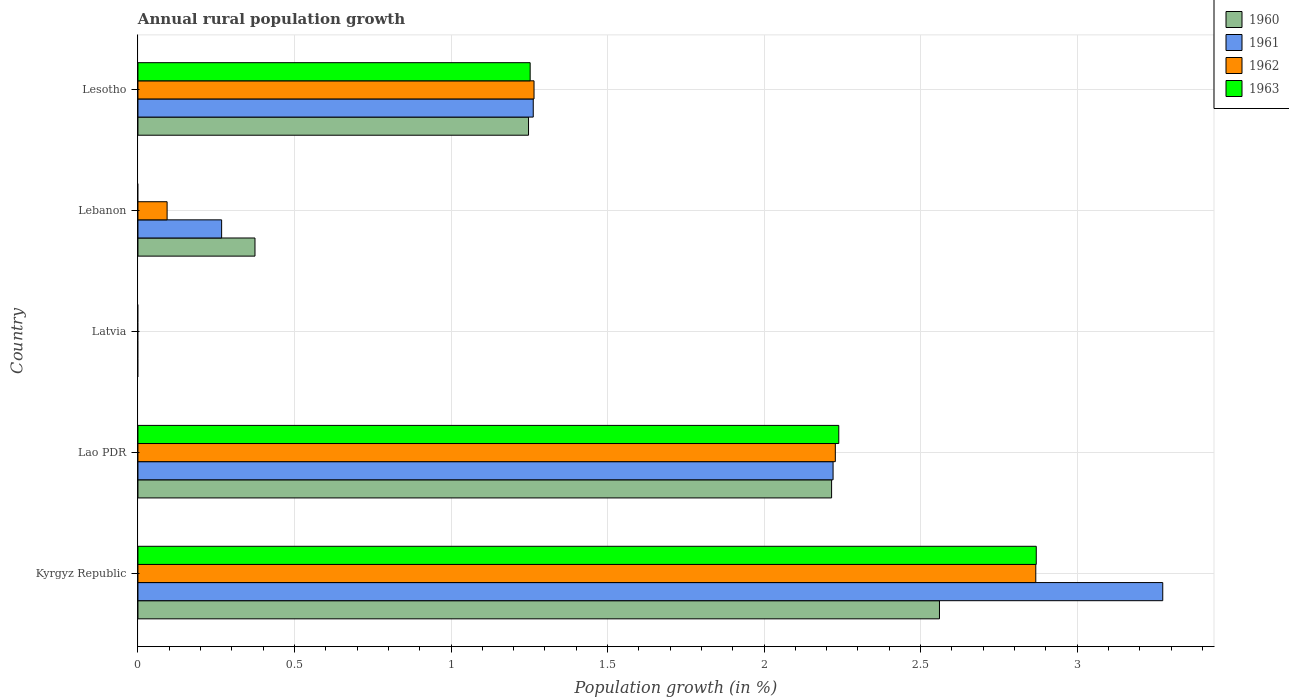Are the number of bars per tick equal to the number of legend labels?
Keep it short and to the point. No. Are the number of bars on each tick of the Y-axis equal?
Offer a very short reply. No. How many bars are there on the 5th tick from the top?
Offer a very short reply. 4. What is the label of the 1st group of bars from the top?
Keep it short and to the point. Lesotho. In how many cases, is the number of bars for a given country not equal to the number of legend labels?
Keep it short and to the point. 2. What is the percentage of rural population growth in 1960 in Lebanon?
Provide a short and direct response. 0.37. Across all countries, what is the maximum percentage of rural population growth in 1962?
Provide a succinct answer. 2.87. Across all countries, what is the minimum percentage of rural population growth in 1960?
Your answer should be compact. 0. In which country was the percentage of rural population growth in 1962 maximum?
Your answer should be compact. Kyrgyz Republic. What is the total percentage of rural population growth in 1961 in the graph?
Make the answer very short. 7.02. What is the difference between the percentage of rural population growth in 1960 in Kyrgyz Republic and that in Lebanon?
Your answer should be very brief. 2.19. What is the difference between the percentage of rural population growth in 1963 in Kyrgyz Republic and the percentage of rural population growth in 1960 in Lesotho?
Ensure brevity in your answer.  1.62. What is the average percentage of rural population growth in 1962 per country?
Ensure brevity in your answer.  1.29. What is the difference between the percentage of rural population growth in 1960 and percentage of rural population growth in 1963 in Lao PDR?
Your answer should be compact. -0.02. What is the ratio of the percentage of rural population growth in 1962 in Lao PDR to that in Lesotho?
Your response must be concise. 1.76. What is the difference between the highest and the second highest percentage of rural population growth in 1962?
Provide a short and direct response. 0.64. What is the difference between the highest and the lowest percentage of rural population growth in 1963?
Provide a succinct answer. 2.87. How many bars are there?
Offer a very short reply. 15. What is the difference between two consecutive major ticks on the X-axis?
Make the answer very short. 0.5. Does the graph contain any zero values?
Your response must be concise. Yes. How many legend labels are there?
Your answer should be very brief. 4. How are the legend labels stacked?
Make the answer very short. Vertical. What is the title of the graph?
Provide a short and direct response. Annual rural population growth. What is the label or title of the X-axis?
Offer a terse response. Population growth (in %). What is the label or title of the Y-axis?
Keep it short and to the point. Country. What is the Population growth (in %) in 1960 in Kyrgyz Republic?
Provide a short and direct response. 2.56. What is the Population growth (in %) in 1961 in Kyrgyz Republic?
Keep it short and to the point. 3.27. What is the Population growth (in %) in 1962 in Kyrgyz Republic?
Your response must be concise. 2.87. What is the Population growth (in %) of 1963 in Kyrgyz Republic?
Ensure brevity in your answer.  2.87. What is the Population growth (in %) of 1960 in Lao PDR?
Offer a very short reply. 2.22. What is the Population growth (in %) in 1961 in Lao PDR?
Your answer should be compact. 2.22. What is the Population growth (in %) of 1962 in Lao PDR?
Offer a very short reply. 2.23. What is the Population growth (in %) of 1963 in Lao PDR?
Your response must be concise. 2.24. What is the Population growth (in %) in 1961 in Latvia?
Provide a succinct answer. 0. What is the Population growth (in %) of 1962 in Latvia?
Your response must be concise. 0. What is the Population growth (in %) of 1963 in Latvia?
Offer a terse response. 0. What is the Population growth (in %) in 1960 in Lebanon?
Give a very brief answer. 0.37. What is the Population growth (in %) of 1961 in Lebanon?
Offer a terse response. 0.27. What is the Population growth (in %) in 1962 in Lebanon?
Keep it short and to the point. 0.09. What is the Population growth (in %) of 1963 in Lebanon?
Keep it short and to the point. 0. What is the Population growth (in %) in 1960 in Lesotho?
Ensure brevity in your answer.  1.25. What is the Population growth (in %) in 1961 in Lesotho?
Offer a very short reply. 1.26. What is the Population growth (in %) of 1962 in Lesotho?
Offer a terse response. 1.27. What is the Population growth (in %) in 1963 in Lesotho?
Ensure brevity in your answer.  1.25. Across all countries, what is the maximum Population growth (in %) of 1960?
Provide a short and direct response. 2.56. Across all countries, what is the maximum Population growth (in %) of 1961?
Offer a terse response. 3.27. Across all countries, what is the maximum Population growth (in %) of 1962?
Provide a short and direct response. 2.87. Across all countries, what is the maximum Population growth (in %) in 1963?
Provide a short and direct response. 2.87. Across all countries, what is the minimum Population growth (in %) in 1962?
Offer a terse response. 0. Across all countries, what is the minimum Population growth (in %) in 1963?
Give a very brief answer. 0. What is the total Population growth (in %) in 1960 in the graph?
Offer a terse response. 6.4. What is the total Population growth (in %) of 1961 in the graph?
Offer a very short reply. 7.02. What is the total Population growth (in %) in 1962 in the graph?
Give a very brief answer. 6.45. What is the total Population growth (in %) of 1963 in the graph?
Ensure brevity in your answer.  6.36. What is the difference between the Population growth (in %) of 1960 in Kyrgyz Republic and that in Lao PDR?
Your answer should be very brief. 0.34. What is the difference between the Population growth (in %) in 1961 in Kyrgyz Republic and that in Lao PDR?
Your response must be concise. 1.05. What is the difference between the Population growth (in %) of 1962 in Kyrgyz Republic and that in Lao PDR?
Keep it short and to the point. 0.64. What is the difference between the Population growth (in %) in 1963 in Kyrgyz Republic and that in Lao PDR?
Your response must be concise. 0.63. What is the difference between the Population growth (in %) in 1960 in Kyrgyz Republic and that in Lebanon?
Offer a terse response. 2.19. What is the difference between the Population growth (in %) in 1961 in Kyrgyz Republic and that in Lebanon?
Your answer should be very brief. 3.01. What is the difference between the Population growth (in %) in 1962 in Kyrgyz Republic and that in Lebanon?
Offer a very short reply. 2.77. What is the difference between the Population growth (in %) in 1960 in Kyrgyz Republic and that in Lesotho?
Give a very brief answer. 1.31. What is the difference between the Population growth (in %) in 1961 in Kyrgyz Republic and that in Lesotho?
Your answer should be very brief. 2.01. What is the difference between the Population growth (in %) in 1962 in Kyrgyz Republic and that in Lesotho?
Make the answer very short. 1.6. What is the difference between the Population growth (in %) in 1963 in Kyrgyz Republic and that in Lesotho?
Your answer should be compact. 1.62. What is the difference between the Population growth (in %) of 1960 in Lao PDR and that in Lebanon?
Ensure brevity in your answer.  1.84. What is the difference between the Population growth (in %) in 1961 in Lao PDR and that in Lebanon?
Your answer should be compact. 1.95. What is the difference between the Population growth (in %) in 1962 in Lao PDR and that in Lebanon?
Your answer should be compact. 2.13. What is the difference between the Population growth (in %) in 1960 in Lao PDR and that in Lesotho?
Your response must be concise. 0.97. What is the difference between the Population growth (in %) in 1961 in Lao PDR and that in Lesotho?
Make the answer very short. 0.96. What is the difference between the Population growth (in %) of 1962 in Lao PDR and that in Lesotho?
Keep it short and to the point. 0.96. What is the difference between the Population growth (in %) in 1963 in Lao PDR and that in Lesotho?
Your answer should be very brief. 0.99. What is the difference between the Population growth (in %) in 1960 in Lebanon and that in Lesotho?
Your answer should be very brief. -0.87. What is the difference between the Population growth (in %) of 1961 in Lebanon and that in Lesotho?
Give a very brief answer. -1. What is the difference between the Population growth (in %) in 1962 in Lebanon and that in Lesotho?
Offer a terse response. -1.17. What is the difference between the Population growth (in %) of 1960 in Kyrgyz Republic and the Population growth (in %) of 1961 in Lao PDR?
Keep it short and to the point. 0.34. What is the difference between the Population growth (in %) of 1960 in Kyrgyz Republic and the Population growth (in %) of 1962 in Lao PDR?
Ensure brevity in your answer.  0.33. What is the difference between the Population growth (in %) in 1960 in Kyrgyz Republic and the Population growth (in %) in 1963 in Lao PDR?
Your answer should be compact. 0.32. What is the difference between the Population growth (in %) of 1961 in Kyrgyz Republic and the Population growth (in %) of 1962 in Lao PDR?
Provide a short and direct response. 1.05. What is the difference between the Population growth (in %) in 1961 in Kyrgyz Republic and the Population growth (in %) in 1963 in Lao PDR?
Keep it short and to the point. 1.03. What is the difference between the Population growth (in %) in 1962 in Kyrgyz Republic and the Population growth (in %) in 1963 in Lao PDR?
Offer a terse response. 0.63. What is the difference between the Population growth (in %) in 1960 in Kyrgyz Republic and the Population growth (in %) in 1961 in Lebanon?
Your response must be concise. 2.29. What is the difference between the Population growth (in %) of 1960 in Kyrgyz Republic and the Population growth (in %) of 1962 in Lebanon?
Your answer should be very brief. 2.47. What is the difference between the Population growth (in %) of 1961 in Kyrgyz Republic and the Population growth (in %) of 1962 in Lebanon?
Your response must be concise. 3.18. What is the difference between the Population growth (in %) in 1960 in Kyrgyz Republic and the Population growth (in %) in 1961 in Lesotho?
Make the answer very short. 1.3. What is the difference between the Population growth (in %) of 1960 in Kyrgyz Republic and the Population growth (in %) of 1962 in Lesotho?
Your answer should be compact. 1.3. What is the difference between the Population growth (in %) of 1960 in Kyrgyz Republic and the Population growth (in %) of 1963 in Lesotho?
Your response must be concise. 1.31. What is the difference between the Population growth (in %) of 1961 in Kyrgyz Republic and the Population growth (in %) of 1962 in Lesotho?
Your answer should be compact. 2.01. What is the difference between the Population growth (in %) of 1961 in Kyrgyz Republic and the Population growth (in %) of 1963 in Lesotho?
Provide a short and direct response. 2.02. What is the difference between the Population growth (in %) of 1962 in Kyrgyz Republic and the Population growth (in %) of 1963 in Lesotho?
Your response must be concise. 1.62. What is the difference between the Population growth (in %) of 1960 in Lao PDR and the Population growth (in %) of 1961 in Lebanon?
Keep it short and to the point. 1.95. What is the difference between the Population growth (in %) in 1960 in Lao PDR and the Population growth (in %) in 1962 in Lebanon?
Provide a succinct answer. 2.12. What is the difference between the Population growth (in %) of 1961 in Lao PDR and the Population growth (in %) of 1962 in Lebanon?
Keep it short and to the point. 2.13. What is the difference between the Population growth (in %) in 1960 in Lao PDR and the Population growth (in %) in 1961 in Lesotho?
Provide a succinct answer. 0.95. What is the difference between the Population growth (in %) of 1960 in Lao PDR and the Population growth (in %) of 1962 in Lesotho?
Give a very brief answer. 0.95. What is the difference between the Population growth (in %) in 1960 in Lao PDR and the Population growth (in %) in 1963 in Lesotho?
Keep it short and to the point. 0.96. What is the difference between the Population growth (in %) in 1961 in Lao PDR and the Population growth (in %) in 1962 in Lesotho?
Your response must be concise. 0.96. What is the difference between the Population growth (in %) in 1961 in Lao PDR and the Population growth (in %) in 1963 in Lesotho?
Offer a very short reply. 0.97. What is the difference between the Population growth (in %) in 1962 in Lao PDR and the Population growth (in %) in 1963 in Lesotho?
Offer a very short reply. 0.97. What is the difference between the Population growth (in %) in 1960 in Lebanon and the Population growth (in %) in 1961 in Lesotho?
Give a very brief answer. -0.89. What is the difference between the Population growth (in %) in 1960 in Lebanon and the Population growth (in %) in 1962 in Lesotho?
Your answer should be very brief. -0.89. What is the difference between the Population growth (in %) in 1960 in Lebanon and the Population growth (in %) in 1963 in Lesotho?
Offer a very short reply. -0.88. What is the difference between the Population growth (in %) in 1961 in Lebanon and the Population growth (in %) in 1962 in Lesotho?
Your answer should be very brief. -1. What is the difference between the Population growth (in %) of 1961 in Lebanon and the Population growth (in %) of 1963 in Lesotho?
Provide a succinct answer. -0.99. What is the difference between the Population growth (in %) of 1962 in Lebanon and the Population growth (in %) of 1963 in Lesotho?
Make the answer very short. -1.16. What is the average Population growth (in %) of 1960 per country?
Provide a succinct answer. 1.28. What is the average Population growth (in %) in 1961 per country?
Offer a very short reply. 1.4. What is the average Population growth (in %) of 1962 per country?
Give a very brief answer. 1.29. What is the average Population growth (in %) in 1963 per country?
Give a very brief answer. 1.27. What is the difference between the Population growth (in %) in 1960 and Population growth (in %) in 1961 in Kyrgyz Republic?
Your answer should be very brief. -0.71. What is the difference between the Population growth (in %) in 1960 and Population growth (in %) in 1962 in Kyrgyz Republic?
Provide a short and direct response. -0.31. What is the difference between the Population growth (in %) of 1960 and Population growth (in %) of 1963 in Kyrgyz Republic?
Provide a short and direct response. -0.31. What is the difference between the Population growth (in %) in 1961 and Population growth (in %) in 1962 in Kyrgyz Republic?
Provide a short and direct response. 0.41. What is the difference between the Population growth (in %) in 1961 and Population growth (in %) in 1963 in Kyrgyz Republic?
Your answer should be very brief. 0.4. What is the difference between the Population growth (in %) in 1962 and Population growth (in %) in 1963 in Kyrgyz Republic?
Offer a very short reply. -0. What is the difference between the Population growth (in %) in 1960 and Population growth (in %) in 1961 in Lao PDR?
Your response must be concise. -0. What is the difference between the Population growth (in %) of 1960 and Population growth (in %) of 1962 in Lao PDR?
Make the answer very short. -0.01. What is the difference between the Population growth (in %) in 1960 and Population growth (in %) in 1963 in Lao PDR?
Provide a succinct answer. -0.02. What is the difference between the Population growth (in %) of 1961 and Population growth (in %) of 1962 in Lao PDR?
Make the answer very short. -0.01. What is the difference between the Population growth (in %) of 1961 and Population growth (in %) of 1963 in Lao PDR?
Provide a succinct answer. -0.02. What is the difference between the Population growth (in %) of 1962 and Population growth (in %) of 1963 in Lao PDR?
Offer a terse response. -0.01. What is the difference between the Population growth (in %) of 1960 and Population growth (in %) of 1961 in Lebanon?
Your response must be concise. 0.11. What is the difference between the Population growth (in %) in 1960 and Population growth (in %) in 1962 in Lebanon?
Offer a terse response. 0.28. What is the difference between the Population growth (in %) in 1961 and Population growth (in %) in 1962 in Lebanon?
Offer a very short reply. 0.17. What is the difference between the Population growth (in %) in 1960 and Population growth (in %) in 1961 in Lesotho?
Your response must be concise. -0.01. What is the difference between the Population growth (in %) of 1960 and Population growth (in %) of 1962 in Lesotho?
Offer a very short reply. -0.02. What is the difference between the Population growth (in %) in 1960 and Population growth (in %) in 1963 in Lesotho?
Your answer should be very brief. -0.01. What is the difference between the Population growth (in %) in 1961 and Population growth (in %) in 1962 in Lesotho?
Your response must be concise. -0. What is the difference between the Population growth (in %) in 1961 and Population growth (in %) in 1963 in Lesotho?
Offer a terse response. 0.01. What is the difference between the Population growth (in %) in 1962 and Population growth (in %) in 1963 in Lesotho?
Offer a very short reply. 0.01. What is the ratio of the Population growth (in %) of 1960 in Kyrgyz Republic to that in Lao PDR?
Your response must be concise. 1.16. What is the ratio of the Population growth (in %) in 1961 in Kyrgyz Republic to that in Lao PDR?
Ensure brevity in your answer.  1.47. What is the ratio of the Population growth (in %) of 1962 in Kyrgyz Republic to that in Lao PDR?
Make the answer very short. 1.29. What is the ratio of the Population growth (in %) in 1963 in Kyrgyz Republic to that in Lao PDR?
Make the answer very short. 1.28. What is the ratio of the Population growth (in %) in 1960 in Kyrgyz Republic to that in Lebanon?
Your answer should be compact. 6.85. What is the ratio of the Population growth (in %) in 1961 in Kyrgyz Republic to that in Lebanon?
Make the answer very short. 12.25. What is the ratio of the Population growth (in %) of 1962 in Kyrgyz Republic to that in Lebanon?
Offer a terse response. 30.8. What is the ratio of the Population growth (in %) of 1960 in Kyrgyz Republic to that in Lesotho?
Your answer should be compact. 2.05. What is the ratio of the Population growth (in %) of 1961 in Kyrgyz Republic to that in Lesotho?
Provide a short and direct response. 2.59. What is the ratio of the Population growth (in %) in 1962 in Kyrgyz Republic to that in Lesotho?
Your response must be concise. 2.27. What is the ratio of the Population growth (in %) of 1963 in Kyrgyz Republic to that in Lesotho?
Provide a succinct answer. 2.29. What is the ratio of the Population growth (in %) in 1960 in Lao PDR to that in Lebanon?
Your response must be concise. 5.93. What is the ratio of the Population growth (in %) of 1961 in Lao PDR to that in Lebanon?
Give a very brief answer. 8.31. What is the ratio of the Population growth (in %) of 1962 in Lao PDR to that in Lebanon?
Provide a succinct answer. 23.93. What is the ratio of the Population growth (in %) in 1960 in Lao PDR to that in Lesotho?
Offer a very short reply. 1.78. What is the ratio of the Population growth (in %) in 1961 in Lao PDR to that in Lesotho?
Keep it short and to the point. 1.76. What is the ratio of the Population growth (in %) in 1962 in Lao PDR to that in Lesotho?
Offer a terse response. 1.76. What is the ratio of the Population growth (in %) in 1963 in Lao PDR to that in Lesotho?
Keep it short and to the point. 1.79. What is the ratio of the Population growth (in %) in 1960 in Lebanon to that in Lesotho?
Ensure brevity in your answer.  0.3. What is the ratio of the Population growth (in %) in 1961 in Lebanon to that in Lesotho?
Offer a terse response. 0.21. What is the ratio of the Population growth (in %) in 1962 in Lebanon to that in Lesotho?
Offer a very short reply. 0.07. What is the difference between the highest and the second highest Population growth (in %) in 1960?
Offer a terse response. 0.34. What is the difference between the highest and the second highest Population growth (in %) in 1961?
Make the answer very short. 1.05. What is the difference between the highest and the second highest Population growth (in %) of 1962?
Your answer should be compact. 0.64. What is the difference between the highest and the second highest Population growth (in %) of 1963?
Offer a terse response. 0.63. What is the difference between the highest and the lowest Population growth (in %) of 1960?
Your answer should be very brief. 2.56. What is the difference between the highest and the lowest Population growth (in %) in 1961?
Your answer should be very brief. 3.27. What is the difference between the highest and the lowest Population growth (in %) in 1962?
Your answer should be compact. 2.87. What is the difference between the highest and the lowest Population growth (in %) of 1963?
Provide a succinct answer. 2.87. 